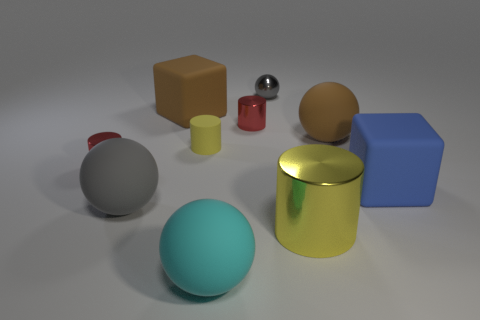What number of other things are the same shape as the cyan matte object?
Provide a short and direct response. 3. Is the number of tiny red shiny cylinders greater than the number of large spheres?
Offer a terse response. No. What number of metal cylinders are both right of the large brown block and in front of the yellow rubber thing?
Offer a very short reply. 1. How many red objects are in front of the small cylinder that is in front of the tiny matte cylinder?
Offer a terse response. 0. How many things are either cylinders that are right of the big gray ball or shiny things on the left side of the small gray metallic ball?
Provide a succinct answer. 4. What is the material of the large brown object that is the same shape as the large gray rubber thing?
Offer a very short reply. Rubber. What number of things are either tiny red cylinders that are in front of the tiny matte cylinder or large yellow balls?
Make the answer very short. 1. There is a yellow thing that is made of the same material as the small sphere; what shape is it?
Your answer should be compact. Cylinder. What number of big gray things have the same shape as the small gray thing?
Keep it short and to the point. 1. What is the tiny sphere made of?
Your answer should be very brief. Metal. 